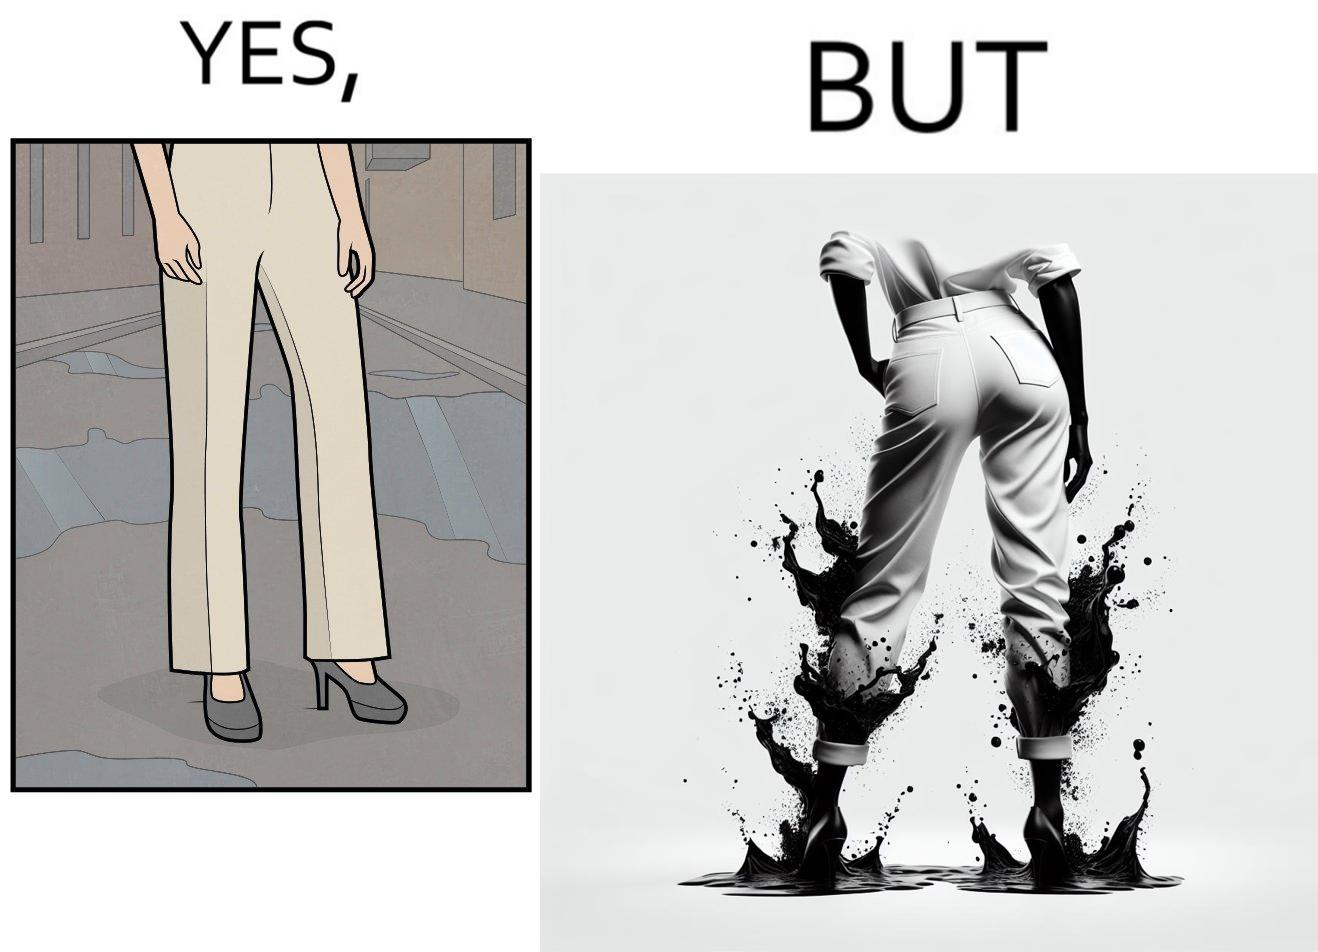Explain the humor or irony in this image. The image is funny, as when looking from the front, girl's pants are spick and span, while looking from the back, her pants are soaked in water, probably due to walking on a road filled with water in high heels. This is ironical, as the very reason for wearing heels (i.e. looking beautiful) is defeated, due to the heels themselves. 